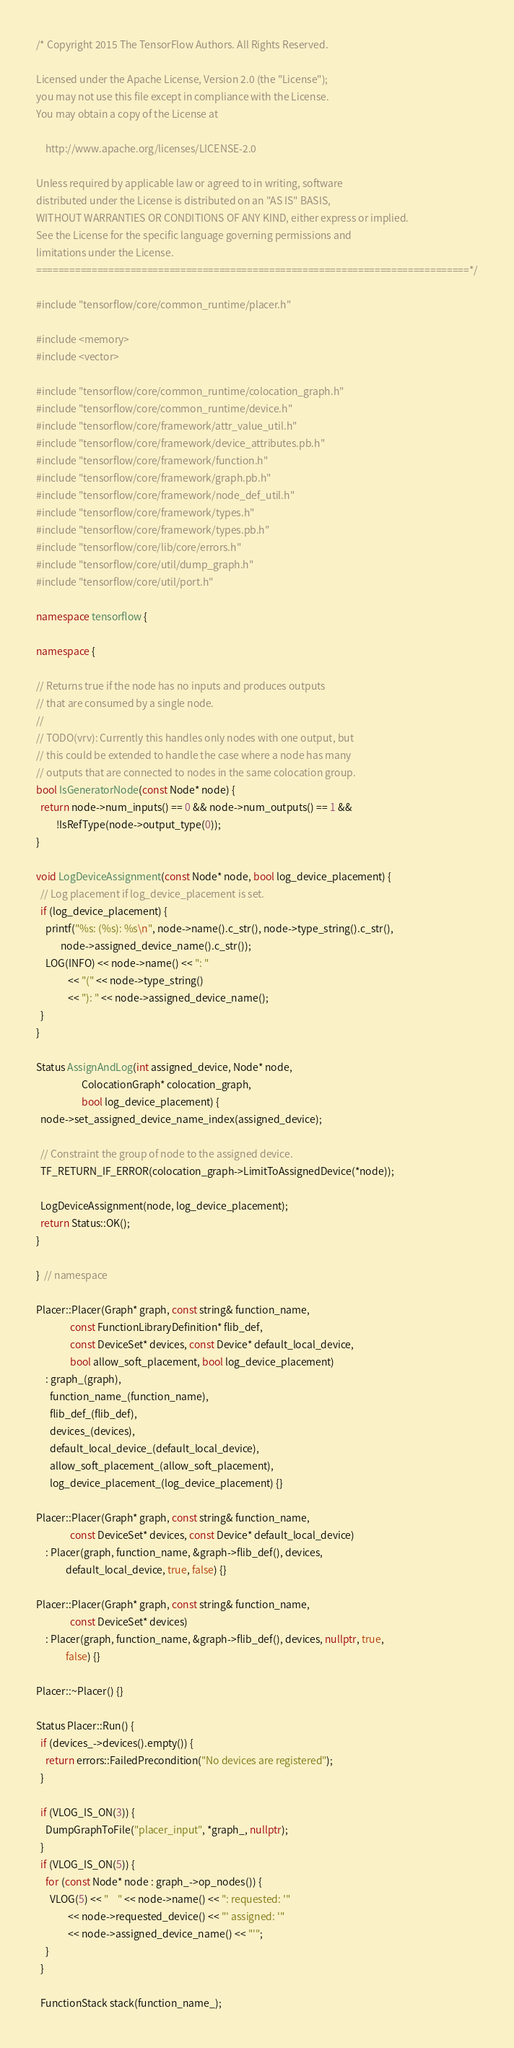Convert code to text. <code><loc_0><loc_0><loc_500><loc_500><_C++_>/* Copyright 2015 The TensorFlow Authors. All Rights Reserved.

Licensed under the Apache License, Version 2.0 (the "License");
you may not use this file except in compliance with the License.
You may obtain a copy of the License at

    http://www.apache.org/licenses/LICENSE-2.0

Unless required by applicable law or agreed to in writing, software
distributed under the License is distributed on an "AS IS" BASIS,
WITHOUT WARRANTIES OR CONDITIONS OF ANY KIND, either express or implied.
See the License for the specific language governing permissions and
limitations under the License.
==============================================================================*/

#include "tensorflow/core/common_runtime/placer.h"

#include <memory>
#include <vector>

#include "tensorflow/core/common_runtime/colocation_graph.h"
#include "tensorflow/core/common_runtime/device.h"
#include "tensorflow/core/framework/attr_value_util.h"
#include "tensorflow/core/framework/device_attributes.pb.h"
#include "tensorflow/core/framework/function.h"
#include "tensorflow/core/framework/graph.pb.h"
#include "tensorflow/core/framework/node_def_util.h"
#include "tensorflow/core/framework/types.h"
#include "tensorflow/core/framework/types.pb.h"
#include "tensorflow/core/lib/core/errors.h"
#include "tensorflow/core/util/dump_graph.h"
#include "tensorflow/core/util/port.h"

namespace tensorflow {

namespace {

// Returns true if the node has no inputs and produces outputs
// that are consumed by a single node.
//
// TODO(vrv): Currently this handles only nodes with one output, but
// this could be extended to handle the case where a node has many
// outputs that are connected to nodes in the same colocation group.
bool IsGeneratorNode(const Node* node) {
  return node->num_inputs() == 0 && node->num_outputs() == 1 &&
         !IsRefType(node->output_type(0));
}

void LogDeviceAssignment(const Node* node, bool log_device_placement) {
  // Log placement if log_device_placement is set.
  if (log_device_placement) {
    printf("%s: (%s): %s\n", node->name().c_str(), node->type_string().c_str(),
           node->assigned_device_name().c_str());
    LOG(INFO) << node->name() << ": "
              << "(" << node->type_string()
              << "): " << node->assigned_device_name();
  }
}

Status AssignAndLog(int assigned_device, Node* node,
                    ColocationGraph* colocation_graph,
                    bool log_device_placement) {
  node->set_assigned_device_name_index(assigned_device);

  // Constraint the group of node to the assigned device.
  TF_RETURN_IF_ERROR(colocation_graph->LimitToAssignedDevice(*node));

  LogDeviceAssignment(node, log_device_placement);
  return Status::OK();
}

}  // namespace

Placer::Placer(Graph* graph, const string& function_name,
               const FunctionLibraryDefinition* flib_def,
               const DeviceSet* devices, const Device* default_local_device,
               bool allow_soft_placement, bool log_device_placement)
    : graph_(graph),
      function_name_(function_name),
      flib_def_(flib_def),
      devices_(devices),
      default_local_device_(default_local_device),
      allow_soft_placement_(allow_soft_placement),
      log_device_placement_(log_device_placement) {}

Placer::Placer(Graph* graph, const string& function_name,
               const DeviceSet* devices, const Device* default_local_device)
    : Placer(graph, function_name, &graph->flib_def(), devices,
             default_local_device, true, false) {}

Placer::Placer(Graph* graph, const string& function_name,
               const DeviceSet* devices)
    : Placer(graph, function_name, &graph->flib_def(), devices, nullptr, true,
             false) {}

Placer::~Placer() {}

Status Placer::Run() {
  if (devices_->devices().empty()) {
    return errors::FailedPrecondition("No devices are registered");
  }

  if (VLOG_IS_ON(3)) {
    DumpGraphToFile("placer_input", *graph_, nullptr);
  }
  if (VLOG_IS_ON(5)) {
    for (const Node* node : graph_->op_nodes()) {
      VLOG(5) << "    " << node->name() << ": requested: '"
              << node->requested_device() << "' assigned: '"
              << node->assigned_device_name() << "'";
    }
  }

  FunctionStack stack(function_name_);</code> 